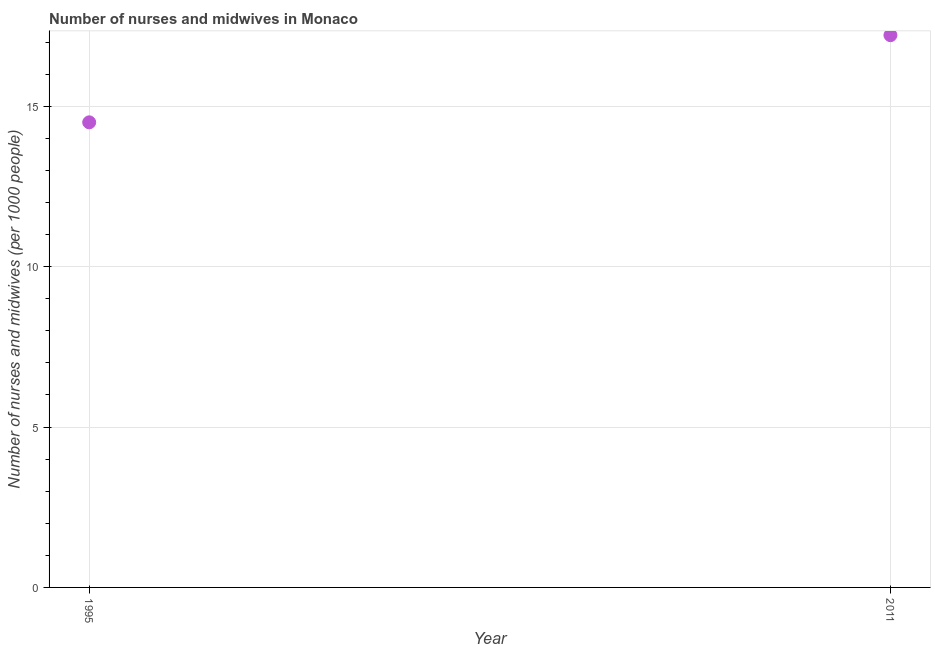Across all years, what is the maximum number of nurses and midwives?
Offer a terse response. 17.22. In which year was the number of nurses and midwives maximum?
Make the answer very short. 2011. What is the sum of the number of nurses and midwives?
Provide a short and direct response. 31.72. What is the difference between the number of nurses and midwives in 1995 and 2011?
Provide a succinct answer. -2.72. What is the average number of nurses and midwives per year?
Give a very brief answer. 15.86. What is the median number of nurses and midwives?
Give a very brief answer. 15.86. In how many years, is the number of nurses and midwives greater than 8 ?
Make the answer very short. 2. Do a majority of the years between 2011 and 1995 (inclusive) have number of nurses and midwives greater than 2 ?
Make the answer very short. No. What is the ratio of the number of nurses and midwives in 1995 to that in 2011?
Your response must be concise. 0.84. What is the difference between two consecutive major ticks on the Y-axis?
Ensure brevity in your answer.  5. Are the values on the major ticks of Y-axis written in scientific E-notation?
Offer a terse response. No. Does the graph contain grids?
Keep it short and to the point. Yes. What is the title of the graph?
Make the answer very short. Number of nurses and midwives in Monaco. What is the label or title of the X-axis?
Ensure brevity in your answer.  Year. What is the label or title of the Y-axis?
Ensure brevity in your answer.  Number of nurses and midwives (per 1000 people). What is the Number of nurses and midwives (per 1000 people) in 1995?
Give a very brief answer. 14.5. What is the Number of nurses and midwives (per 1000 people) in 2011?
Offer a very short reply. 17.22. What is the difference between the Number of nurses and midwives (per 1000 people) in 1995 and 2011?
Offer a very short reply. -2.72. What is the ratio of the Number of nurses and midwives (per 1000 people) in 1995 to that in 2011?
Ensure brevity in your answer.  0.84. 